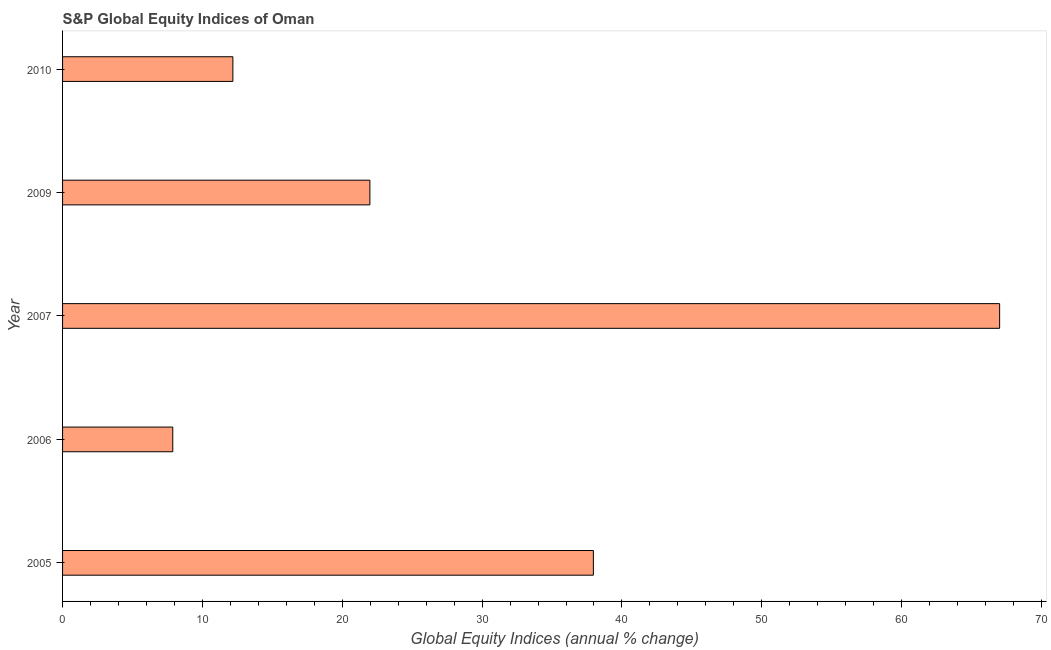Does the graph contain any zero values?
Your response must be concise. No. What is the title of the graph?
Make the answer very short. S&P Global Equity Indices of Oman. What is the label or title of the X-axis?
Offer a terse response. Global Equity Indices (annual % change). What is the label or title of the Y-axis?
Ensure brevity in your answer.  Year. What is the s&p global equity indices in 2007?
Your response must be concise. 67.01. Across all years, what is the maximum s&p global equity indices?
Your answer should be very brief. 67.01. Across all years, what is the minimum s&p global equity indices?
Your answer should be very brief. 7.88. In which year was the s&p global equity indices maximum?
Offer a terse response. 2007. What is the sum of the s&p global equity indices?
Give a very brief answer. 147. What is the difference between the s&p global equity indices in 2006 and 2009?
Your answer should be very brief. -14.1. What is the average s&p global equity indices per year?
Provide a short and direct response. 29.4. What is the median s&p global equity indices?
Your answer should be compact. 21.98. What is the ratio of the s&p global equity indices in 2006 to that in 2007?
Your response must be concise. 0.12. Is the s&p global equity indices in 2009 less than that in 2010?
Ensure brevity in your answer.  No. Is the difference between the s&p global equity indices in 2006 and 2010 greater than the difference between any two years?
Your answer should be very brief. No. What is the difference between the highest and the second highest s&p global equity indices?
Make the answer very short. 29.05. What is the difference between the highest and the lowest s&p global equity indices?
Offer a very short reply. 59.13. In how many years, is the s&p global equity indices greater than the average s&p global equity indices taken over all years?
Ensure brevity in your answer.  2. What is the difference between two consecutive major ticks on the X-axis?
Make the answer very short. 10. Are the values on the major ticks of X-axis written in scientific E-notation?
Offer a very short reply. No. What is the Global Equity Indices (annual % change) in 2005?
Your answer should be compact. 37.96. What is the Global Equity Indices (annual % change) of 2006?
Offer a terse response. 7.88. What is the Global Equity Indices (annual % change) of 2007?
Give a very brief answer. 67.01. What is the Global Equity Indices (annual % change) of 2009?
Your answer should be compact. 21.98. What is the Global Equity Indices (annual % change) in 2010?
Make the answer very short. 12.18. What is the difference between the Global Equity Indices (annual % change) in 2005 and 2006?
Provide a short and direct response. 30.08. What is the difference between the Global Equity Indices (annual % change) in 2005 and 2007?
Give a very brief answer. -29.05. What is the difference between the Global Equity Indices (annual % change) in 2005 and 2009?
Your response must be concise. 15.98. What is the difference between the Global Equity Indices (annual % change) in 2005 and 2010?
Your answer should be very brief. 25.78. What is the difference between the Global Equity Indices (annual % change) in 2006 and 2007?
Provide a short and direct response. -59.13. What is the difference between the Global Equity Indices (annual % change) in 2006 and 2009?
Your response must be concise. -14.1. What is the difference between the Global Equity Indices (annual % change) in 2006 and 2010?
Keep it short and to the point. -4.3. What is the difference between the Global Equity Indices (annual % change) in 2007 and 2009?
Provide a short and direct response. 45.03. What is the difference between the Global Equity Indices (annual % change) in 2007 and 2010?
Provide a succinct answer. 54.83. What is the difference between the Global Equity Indices (annual % change) in 2009 and 2010?
Your answer should be very brief. 9.8. What is the ratio of the Global Equity Indices (annual % change) in 2005 to that in 2006?
Your answer should be very brief. 4.82. What is the ratio of the Global Equity Indices (annual % change) in 2005 to that in 2007?
Make the answer very short. 0.57. What is the ratio of the Global Equity Indices (annual % change) in 2005 to that in 2009?
Provide a short and direct response. 1.73. What is the ratio of the Global Equity Indices (annual % change) in 2005 to that in 2010?
Your response must be concise. 3.12. What is the ratio of the Global Equity Indices (annual % change) in 2006 to that in 2007?
Keep it short and to the point. 0.12. What is the ratio of the Global Equity Indices (annual % change) in 2006 to that in 2009?
Your response must be concise. 0.36. What is the ratio of the Global Equity Indices (annual % change) in 2006 to that in 2010?
Keep it short and to the point. 0.65. What is the ratio of the Global Equity Indices (annual % change) in 2007 to that in 2009?
Offer a very short reply. 3.05. What is the ratio of the Global Equity Indices (annual % change) in 2007 to that in 2010?
Offer a terse response. 5.5. What is the ratio of the Global Equity Indices (annual % change) in 2009 to that in 2010?
Make the answer very short. 1.8. 